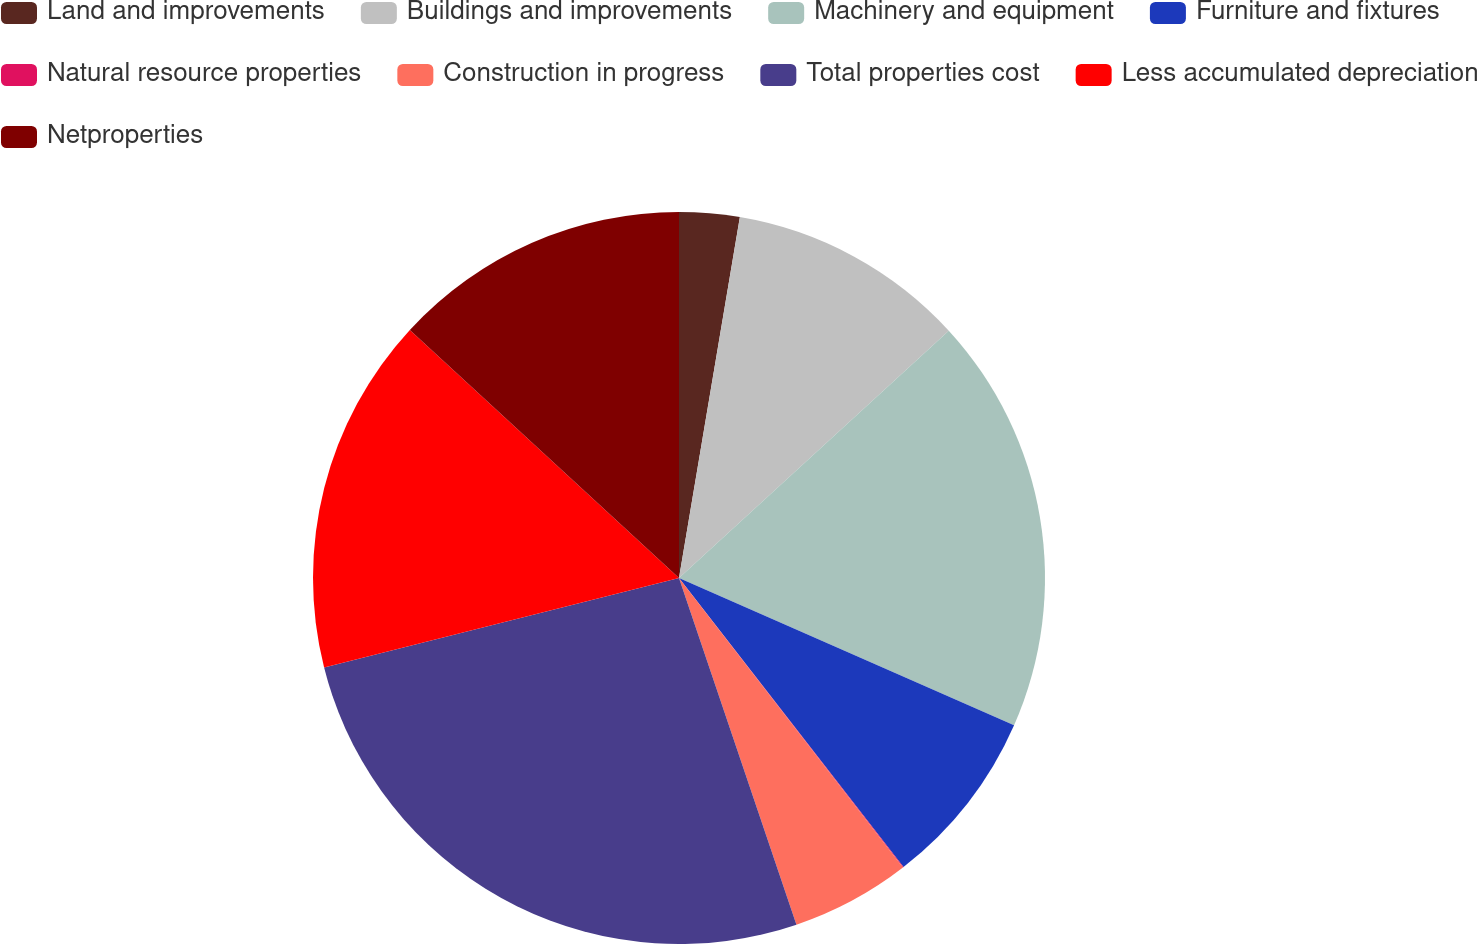Convert chart to OTSL. <chart><loc_0><loc_0><loc_500><loc_500><pie_chart><fcel>Land and improvements<fcel>Buildings and improvements<fcel>Machinery and equipment<fcel>Furniture and fixtures<fcel>Natural resource properties<fcel>Construction in progress<fcel>Total properties cost<fcel>Less accumulated depreciation<fcel>Netproperties<nl><fcel>2.66%<fcel>10.53%<fcel>18.4%<fcel>7.9%<fcel>0.03%<fcel>5.28%<fcel>26.27%<fcel>15.78%<fcel>13.15%<nl></chart> 